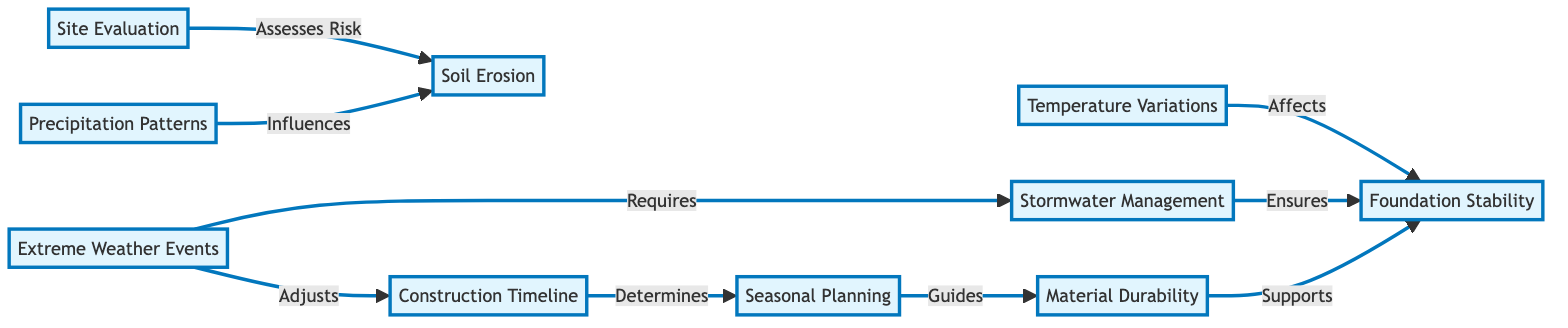What is the primary focus of the "Site Evaluation" node? The "Site Evaluation" node primarily assesses risk related to various factors impacting civil engineering projects.
Answer: Assesses Risk How many nodes are directly influenced by "Precipitation Patterns"? "Precipitation Patterns" influences one node directly, which is "Soil Erosion."
Answer: 1 Which node requires "Stormwater Management"? The "Stormwater Management" is required by the "Extreme Weather Events" node.
Answer: Extreme Weather Events What does "Construction Timeline" determine? The "Construction Timeline" determines the "Seasonal Planning" node in the flowchart.
Answer: Seasonal Planning What two factors influence "Foundation Stability"? "Temperature Variations" and "Stormwater Management" both influence "Foundation Stability."
Answer: Temperature Variations, Stormwater Management How do "Extreme Weather Events" affect "Construction Timeline"? "Extreme Weather Events" adjust the "Construction Timeline" as part of planning for unforeseen circumstances.
Answer: Adjusts What is the relationship between "Material Durability" and "Seasonal Planning"? "Material Durability" is guided by "Seasonal Planning," meaning planning influences how materials will perform over seasons.
Answer: Guides What is the total number of nodes in the diagram? The diagram contains nine nodes in total, which are all major components within the analysis.
Answer: 9 Which node plays a supporting role in the stability of the foundation? The node that supports "Foundation Stability" is "Material Durability," indicating the quality of materials affects foundation strength.
Answer: Material Durability 